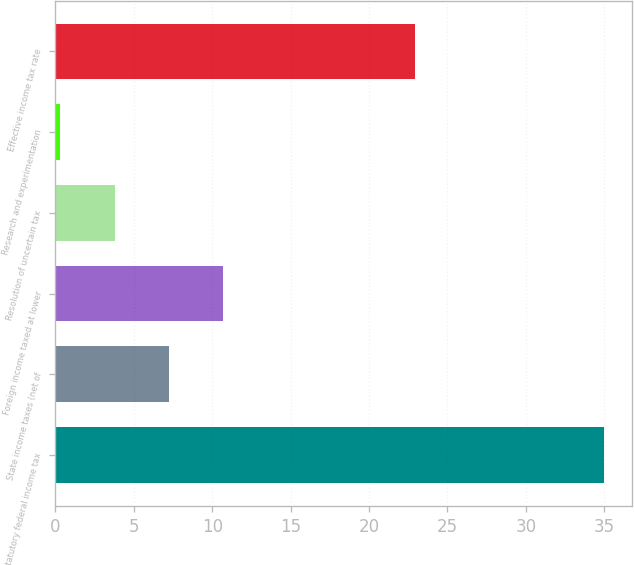Convert chart. <chart><loc_0><loc_0><loc_500><loc_500><bar_chart><fcel>Statutory federal income tax<fcel>State income taxes (net of<fcel>Foreign income taxed at lower<fcel>Resolution of uncertain tax<fcel>Research and experimentation<fcel>Effective income tax rate<nl><fcel>35<fcel>7.24<fcel>10.71<fcel>3.77<fcel>0.3<fcel>22.9<nl></chart> 